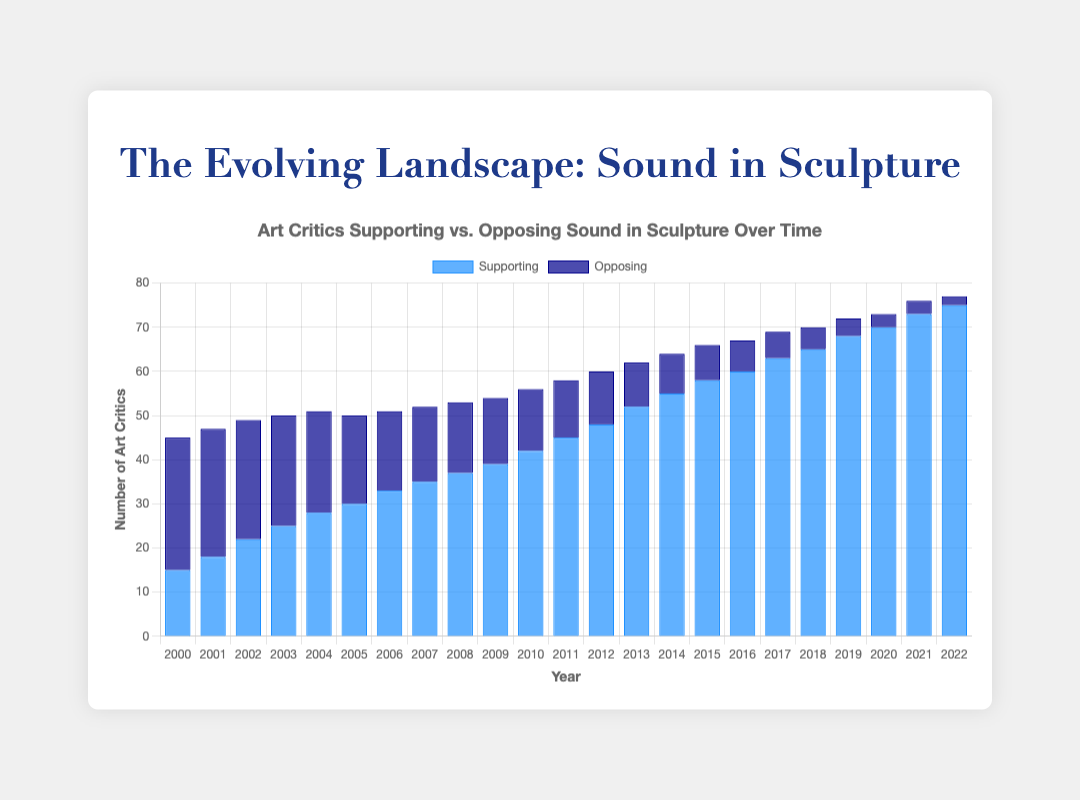What is the general trend in the number of art critics supporting the incorporation of sound in sculptures over the years? Observing the bar chart's visual and comparing the height of the blue bars year after year, the supporting count has been increasing consistently from 2000 to 2022.
Answer: Increasing every year How many more critics supported sound in sculptures than opposed it in 2015? In 2015, there are 58 critics supporting and 8 opposing. To find the difference, subtract the number opposing from the number supporting: 58 - 8.
Answer: 50 What is the average number of art critics supporting sound in sculptures between 2010 and 2014? Sum the supporters from 2010 to 2014 (42 + 45 + 48 + 52 + 55 = 242) and divide by 5 years.
Answer: 48.4 Which year had an equal number of critics supporting and opposing? Comparing the heights of the bars for each year, in 2003 both bars have the same height indicating equal numbers of critics for both categories.
Answer: 2003 By how much did the number of critics opposing sound in sculptures decrease from 2000 to 2005? In 2000, there were 30 critics opposing, and in 2005, there were 20. Subtract the number for 2005 from 2000: 30 - 20.
Answer: 10 What year saw the highest number of art critics opposing sound in sculptures? Checking the heights of the dark blue bars, the tallest bar representing the highest number is in the year 2000.
Answer: 2000 Are there more critics supporting or opposing sound in sculptures in 2021, and by how much? By visually comparing the heights of the bars in 2021, 73 are supporting, and 3 are opposing. The difference is 73 - 3.
Answer: Supporting by 70 How did the number of opposing critics change from 2007 to 2008? The dark blue bar drops from 17 in 2007 to 16 in 2008. The reduction in opposing critics is a difference of 1.
Answer: Decreased by 1 What was the total number of critics (supporting and opposing) in 2010? Sum the number of supporting and opposing critics for 2010: 42 (supporting) + 14 (opposing).
Answer: 56 What’s the difference in the number of supporting critics between 2000 and 2022? The supporting critics were 15 in 2000 and 75 in 2022. Subtract 15 from 75 to get the difference.
Answer: 60 What's the biggest single-year increase in the number of supporting critics, and between which years did this occur? By comparing the increments year by year, the biggest increase is from 2012 to 2013: 52 - 48 = 4.
Answer: 4, between 2012 and 2013 